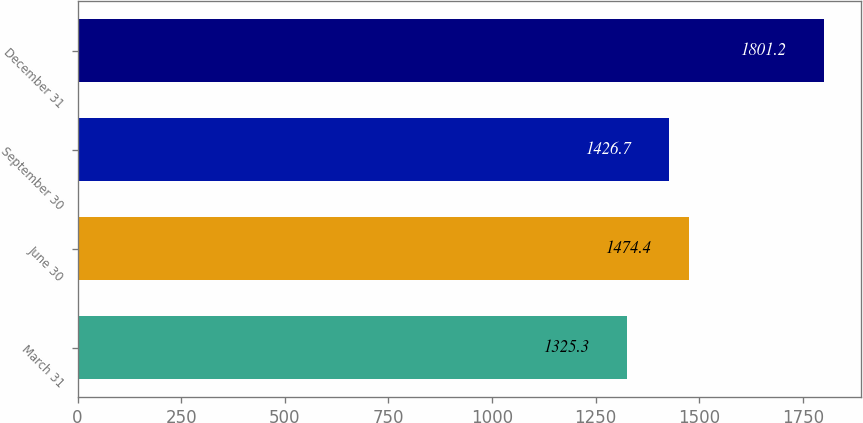<chart> <loc_0><loc_0><loc_500><loc_500><bar_chart><fcel>March 31<fcel>June 30<fcel>September 30<fcel>December 31<nl><fcel>1325.3<fcel>1474.4<fcel>1426.7<fcel>1801.2<nl></chart> 